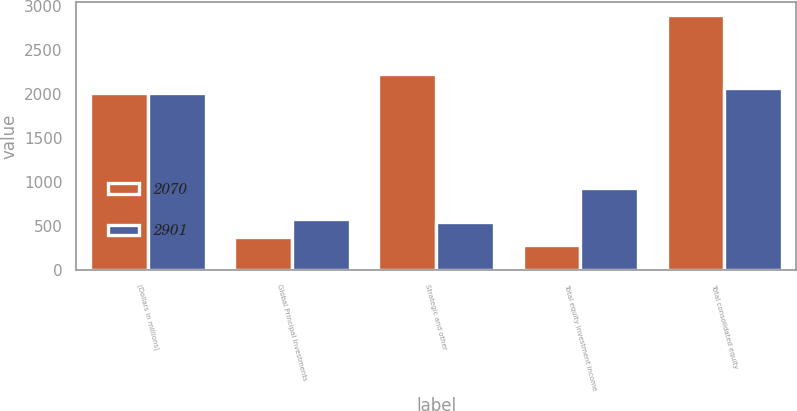Convert chart to OTSL. <chart><loc_0><loc_0><loc_500><loc_500><stacked_bar_chart><ecel><fcel>(Dollars in millions)<fcel>Global Principal Investments<fcel>Strategic and other<fcel>Total equity investment income<fcel>Total consolidated equity<nl><fcel>2070<fcel>2013<fcel>378<fcel>2232<fcel>291<fcel>2901<nl><fcel>2901<fcel>2012<fcel>589<fcel>546<fcel>935<fcel>2070<nl></chart> 